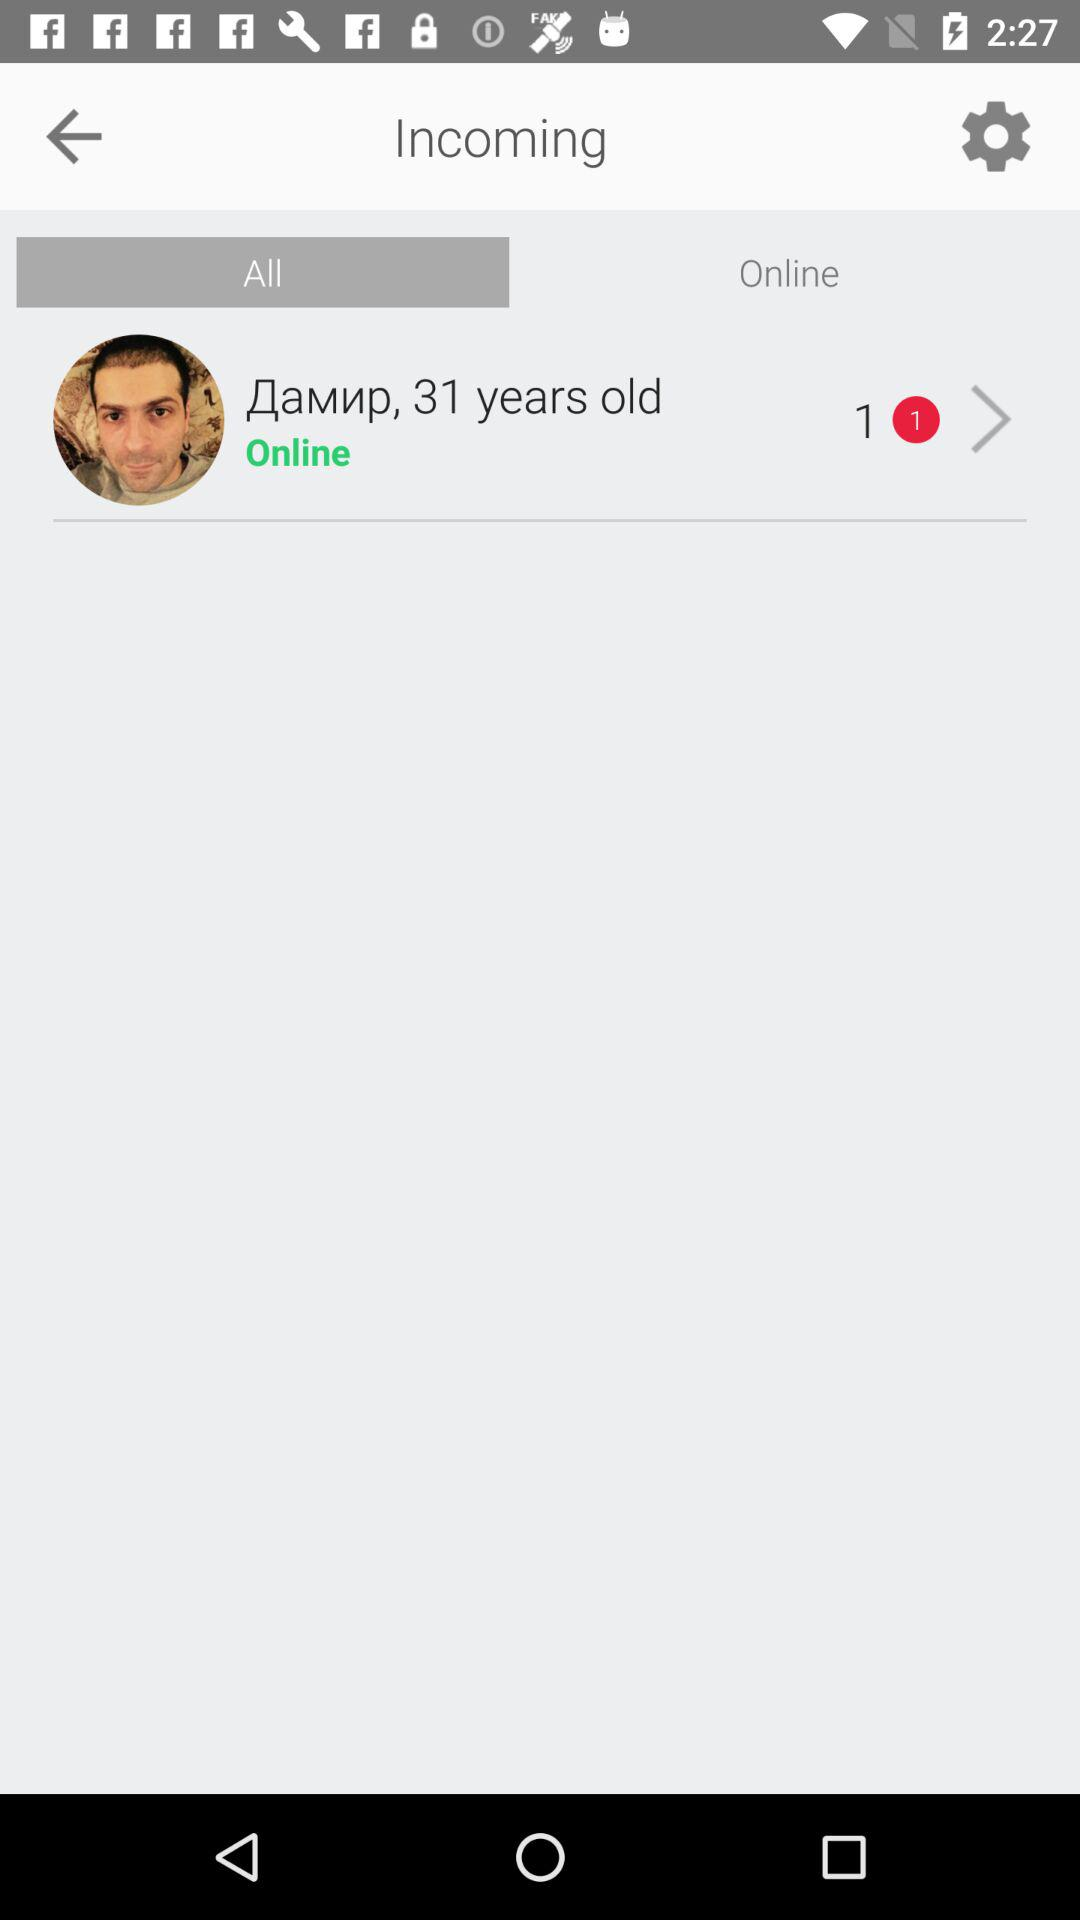What is the age of the person? The person is 31 years old. 